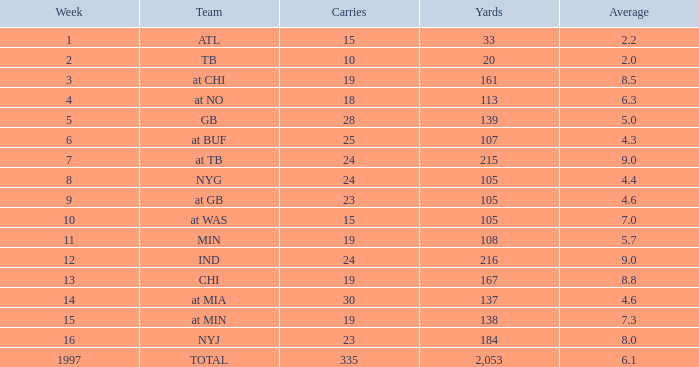What yards have carries fewer than 23, belong to a team at chi, and maintain an average under 8.5? None. 